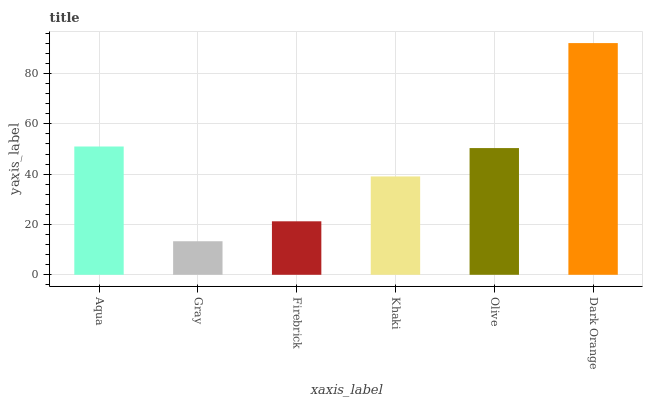Is Gray the minimum?
Answer yes or no. Yes. Is Dark Orange the maximum?
Answer yes or no. Yes. Is Firebrick the minimum?
Answer yes or no. No. Is Firebrick the maximum?
Answer yes or no. No. Is Firebrick greater than Gray?
Answer yes or no. Yes. Is Gray less than Firebrick?
Answer yes or no. Yes. Is Gray greater than Firebrick?
Answer yes or no. No. Is Firebrick less than Gray?
Answer yes or no. No. Is Olive the high median?
Answer yes or no. Yes. Is Khaki the low median?
Answer yes or no. Yes. Is Aqua the high median?
Answer yes or no. No. Is Olive the low median?
Answer yes or no. No. 